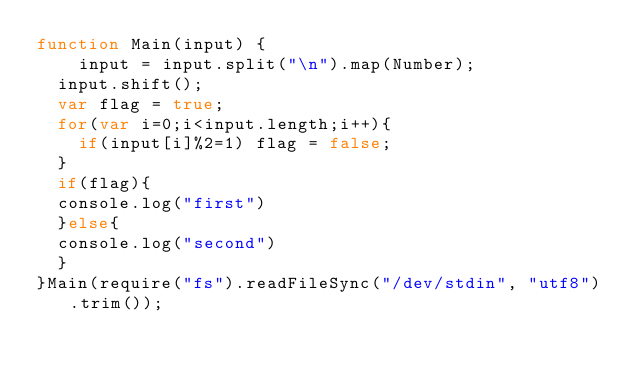Convert code to text. <code><loc_0><loc_0><loc_500><loc_500><_JavaScript_>function Main(input) {
	input = input.split("\n").map(Number);
  input.shift();
  var flag = true;
  for(var i=0;i<input.length;i++){
    if(input[i]%2=1) flag = false;
  }
  if(flag){
  console.log("first")
  }else{
  console.log("second")
  }
}Main(require("fs").readFileSync("/dev/stdin", "utf8").trim());</code> 